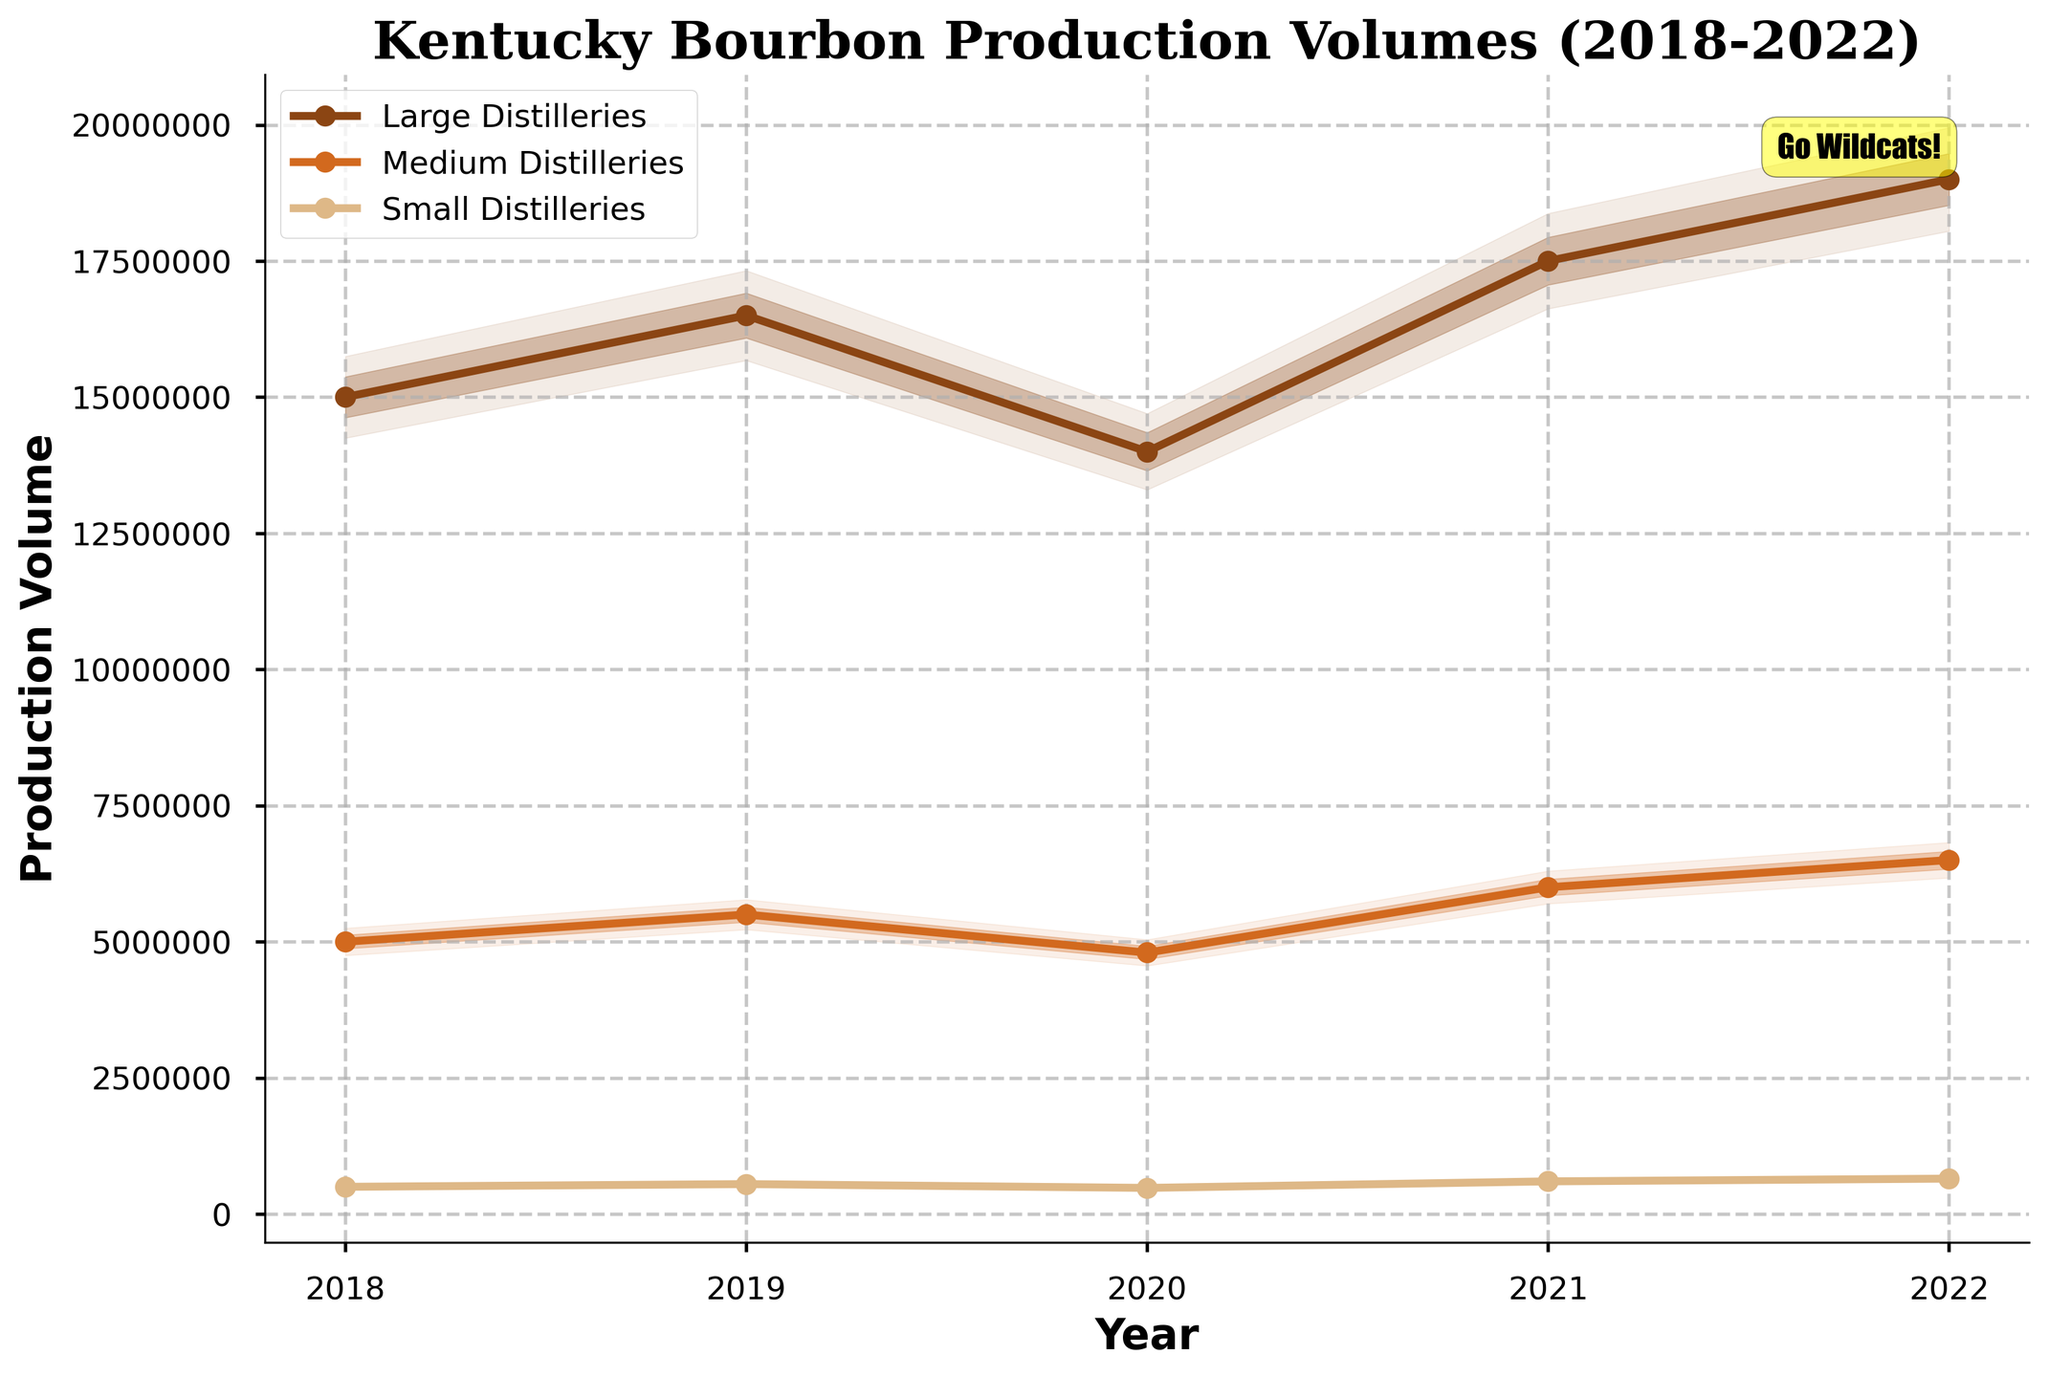what is the title of the chart? The title of the chart is written at the top and gives a brief description of the visual representation, which is essential for understanding the context and content of the plot.
Answer: Kentucky Bourbon Production Volumes (2018-2022) What is the median production volume for Large distilleries in 2020? Median values are plotted as a central line in the fan chart for each distillery size, representing typical production volumes. Look for the median value of Large distilleries for the year 2020.
Answer: 14,000,000 How did the production volume trend for Medium distilleries change from 2018 to 2022? Comparing the lines that represent median values of Medium distilleries for each year, tracked chronologically from 2018 to 2022, shows the trend in production volume.
Answer: Increasing trend Which distillery size had the smallest production volume in 2021? Compare the median production volumes for each distillery size for the year 2021 by looking at their respective central lines.
Answer: Small distilleries Describe the range of production volumes for Small distilleries in 2019. The range of production volumes can be observed as shaded regions around the median line for Small distilleries in 2019. The entire range spans from the lower 10th percentile to the upper 90th percentile.
Answer: 522,500 to 577,500 How do production range variations for Large and Small distilleries differ? Compare the width of shaded areas representing percentiles between the median, lower, and upper bounds for both Large and Small distilleries to understand how much variation exists.
Answer: Larger distilleries show a wider range In which year did Large distilleries see the highest median production volume? Identify the point on the plot where the median line for Large distilleries reached its highest value across the years displayed on the chart.
Answer: 2022 What annotation is present on the figure? Annotations are additional pieces of text or markers added to convey some special information or highlight specific aspects. Look for any annotation in the figure.
Answer: Go Wildcats! Which distillery size shows more consistent production volumes with smaller variation? Compare the spread of the shaded regions (from the 10th to 90th percentiles and from the 25th to 75th percentiles) among different distillery sizes to determine which has the smallest spread, indicating the least variation.
Answer: Small distilleries 